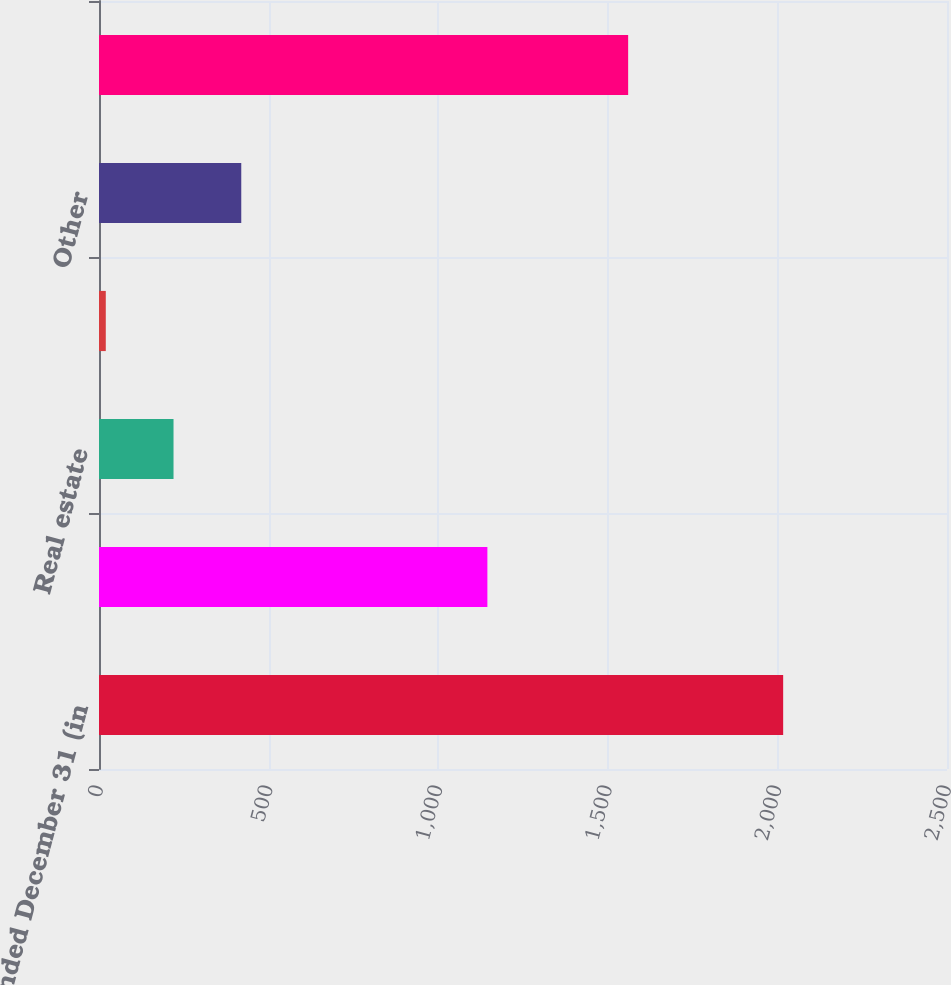Convert chart. <chart><loc_0><loc_0><loc_500><loc_500><bar_chart><fcel>Year ended December 31 (in<fcel>Commercial and industrial<fcel>Real estate<fcel>Financial institutions<fcel>Other<fcel>Total (a)<nl><fcel>2017<fcel>1145<fcel>219.7<fcel>20<fcel>419.4<fcel>1560<nl></chart> 